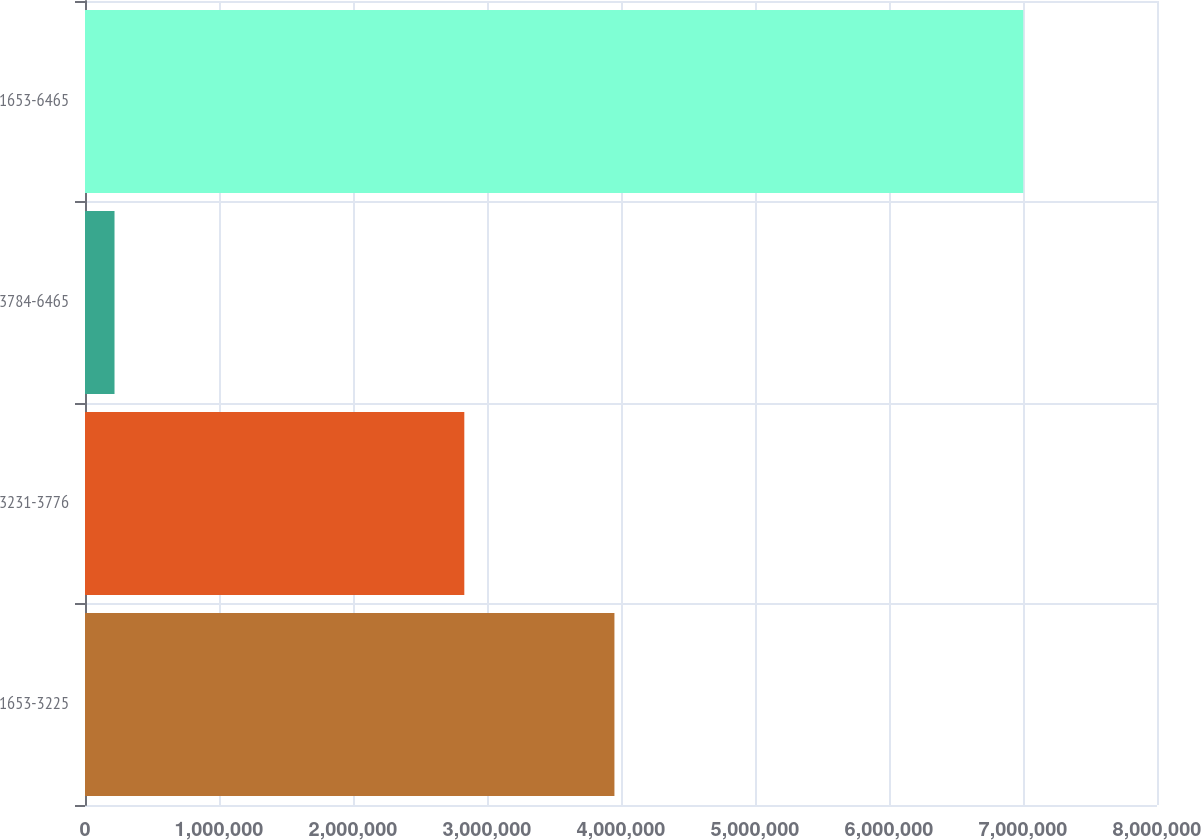Convert chart. <chart><loc_0><loc_0><loc_500><loc_500><bar_chart><fcel>1653-3225<fcel>3231-3776<fcel>3784-6465<fcel>1653-6465<nl><fcel>3.951e+06<fcel>2.83067e+06<fcel>220271<fcel>7.00194e+06<nl></chart> 